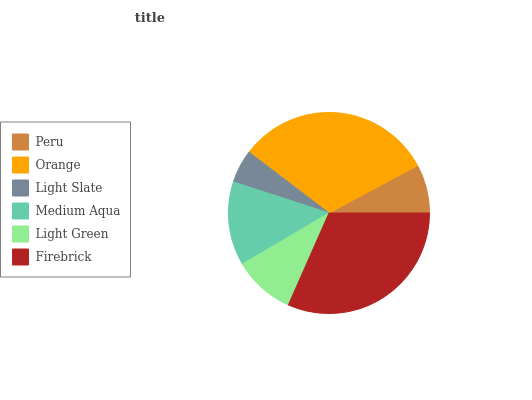Is Light Slate the minimum?
Answer yes or no. Yes. Is Orange the maximum?
Answer yes or no. Yes. Is Orange the minimum?
Answer yes or no. No. Is Light Slate the maximum?
Answer yes or no. No. Is Orange greater than Light Slate?
Answer yes or no. Yes. Is Light Slate less than Orange?
Answer yes or no. Yes. Is Light Slate greater than Orange?
Answer yes or no. No. Is Orange less than Light Slate?
Answer yes or no. No. Is Medium Aqua the high median?
Answer yes or no. Yes. Is Light Green the low median?
Answer yes or no. Yes. Is Light Slate the high median?
Answer yes or no. No. Is Orange the low median?
Answer yes or no. No. 